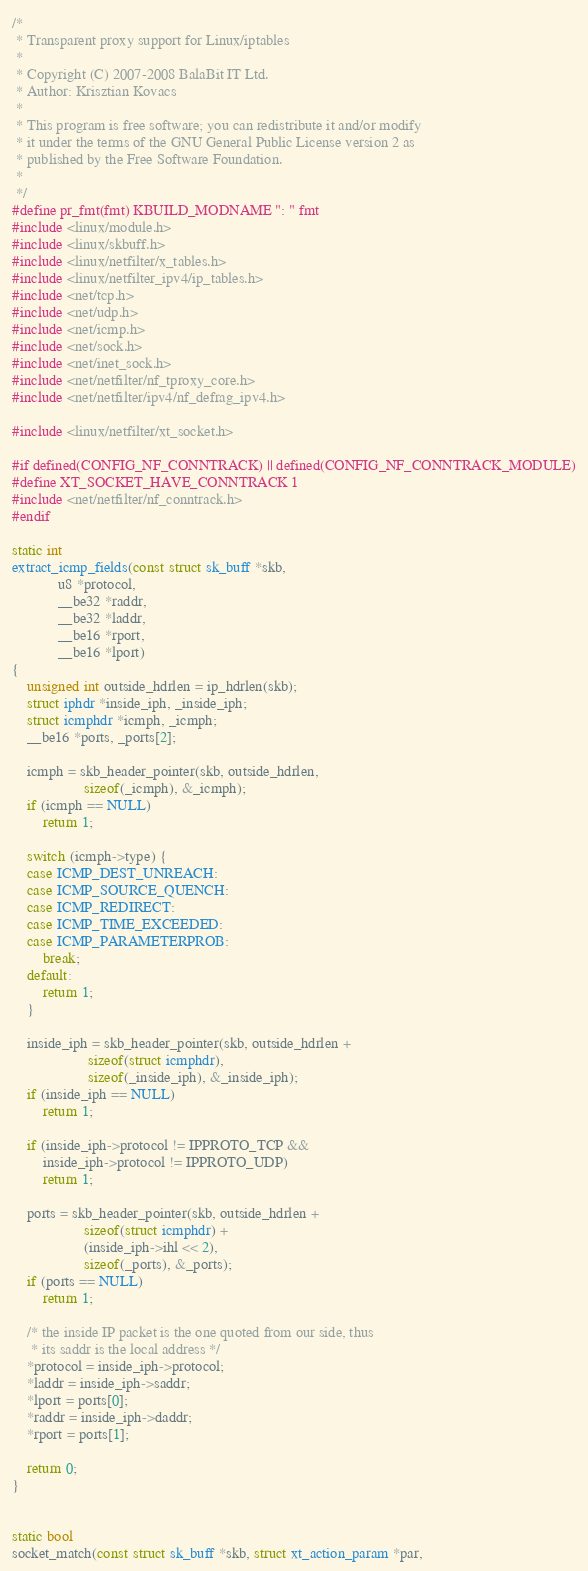Convert code to text. <code><loc_0><loc_0><loc_500><loc_500><_C_>/*
 * Transparent proxy support for Linux/iptables
 *
 * Copyright (C) 2007-2008 BalaBit IT Ltd.
 * Author: Krisztian Kovacs
 *
 * This program is free software; you can redistribute it and/or modify
 * it under the terms of the GNU General Public License version 2 as
 * published by the Free Software Foundation.
 *
 */
#define pr_fmt(fmt) KBUILD_MODNAME ": " fmt
#include <linux/module.h>
#include <linux/skbuff.h>
#include <linux/netfilter/x_tables.h>
#include <linux/netfilter_ipv4/ip_tables.h>
#include <net/tcp.h>
#include <net/udp.h>
#include <net/icmp.h>
#include <net/sock.h>
#include <net/inet_sock.h>
#include <net/netfilter/nf_tproxy_core.h>
#include <net/netfilter/ipv4/nf_defrag_ipv4.h>

#include <linux/netfilter/xt_socket.h>

#if defined(CONFIG_NF_CONNTRACK) || defined(CONFIG_NF_CONNTRACK_MODULE)
#define XT_SOCKET_HAVE_CONNTRACK 1
#include <net/netfilter/nf_conntrack.h>
#endif

static int
extract_icmp_fields(const struct sk_buff *skb,
		    u8 *protocol,
		    __be32 *raddr,
		    __be32 *laddr,
		    __be16 *rport,
		    __be16 *lport)
{
	unsigned int outside_hdrlen = ip_hdrlen(skb);
	struct iphdr *inside_iph, _inside_iph;
	struct icmphdr *icmph, _icmph;
	__be16 *ports, _ports[2];

	icmph = skb_header_pointer(skb, outside_hdrlen,
				   sizeof(_icmph), &_icmph);
	if (icmph == NULL)
		return 1;

	switch (icmph->type) {
	case ICMP_DEST_UNREACH:
	case ICMP_SOURCE_QUENCH:
	case ICMP_REDIRECT:
	case ICMP_TIME_EXCEEDED:
	case ICMP_PARAMETERPROB:
		break;
	default:
		return 1;
	}

	inside_iph = skb_header_pointer(skb, outside_hdrlen +
					sizeof(struct icmphdr),
					sizeof(_inside_iph), &_inside_iph);
	if (inside_iph == NULL)
		return 1;

	if (inside_iph->protocol != IPPROTO_TCP &&
	    inside_iph->protocol != IPPROTO_UDP)
		return 1;

	ports = skb_header_pointer(skb, outside_hdrlen +
				   sizeof(struct icmphdr) +
				   (inside_iph->ihl << 2),
				   sizeof(_ports), &_ports);
	if (ports == NULL)
		return 1;

	/* the inside IP packet is the one quoted from our side, thus
	 * its saddr is the local address */
	*protocol = inside_iph->protocol;
	*laddr = inside_iph->saddr;
	*lport = ports[0];
	*raddr = inside_iph->daddr;
	*rport = ports[1];

	return 0;
}


static bool
socket_match(const struct sk_buff *skb, struct xt_action_param *par,</code> 